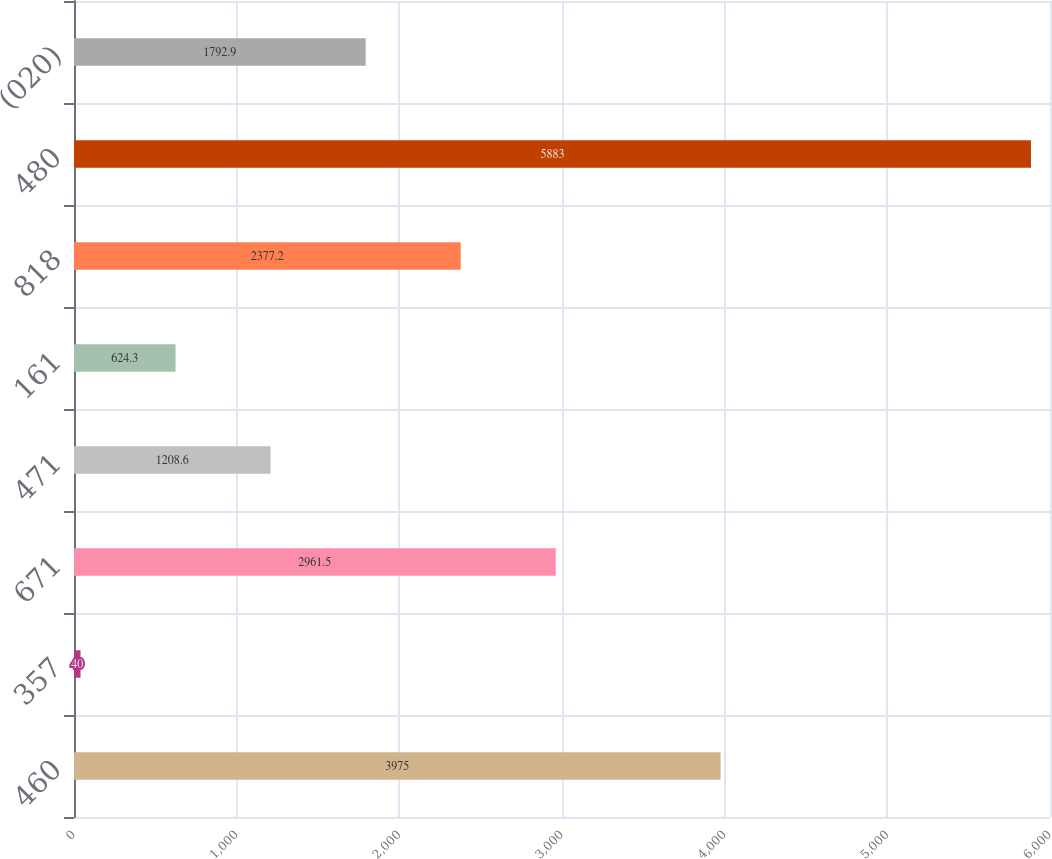Convert chart to OTSL. <chart><loc_0><loc_0><loc_500><loc_500><bar_chart><fcel>460<fcel>357<fcel>671<fcel>471<fcel>161<fcel>818<fcel>480<fcel>(020)<nl><fcel>3975<fcel>40<fcel>2961.5<fcel>1208.6<fcel>624.3<fcel>2377.2<fcel>5883<fcel>1792.9<nl></chart> 